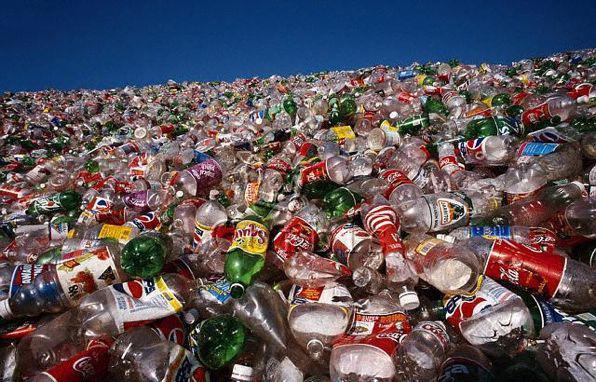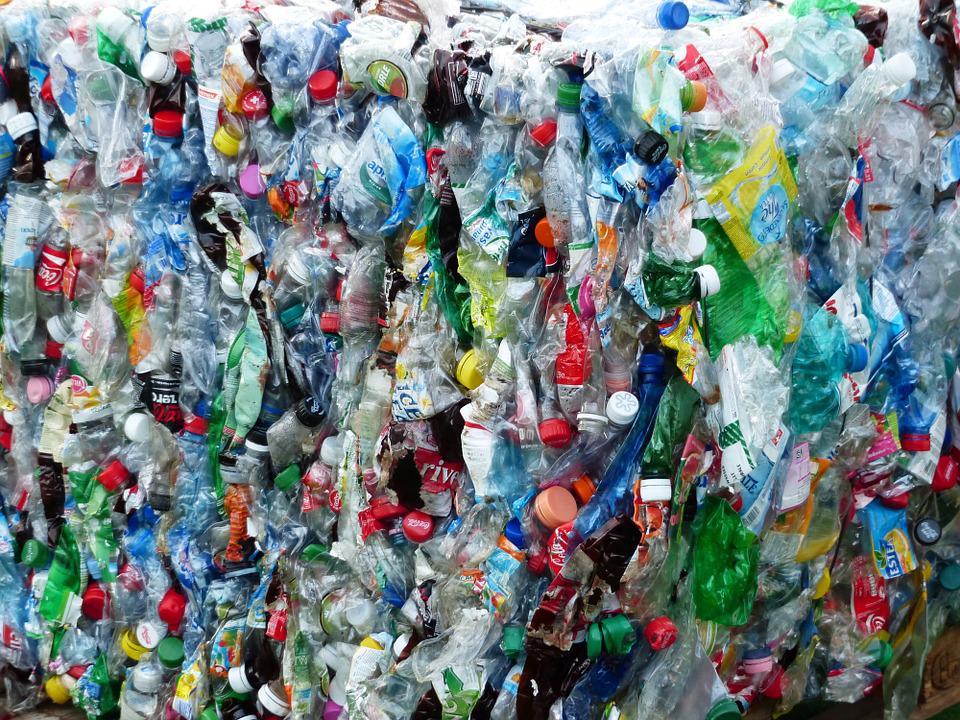The first image is the image on the left, the second image is the image on the right. Considering the images on both sides, is "One of the images contains two or fewer bottles." valid? Answer yes or no. No. The first image is the image on the left, the second image is the image on the right. Considering the images on both sides, is "Some bottles are cut open." valid? Answer yes or no. No. 